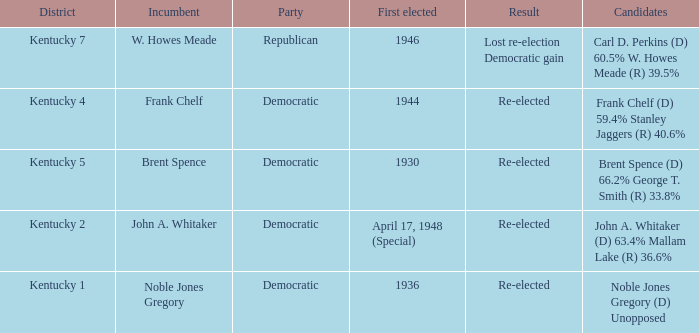Which party won in the election in voting district Kentucky 5? Democratic. 